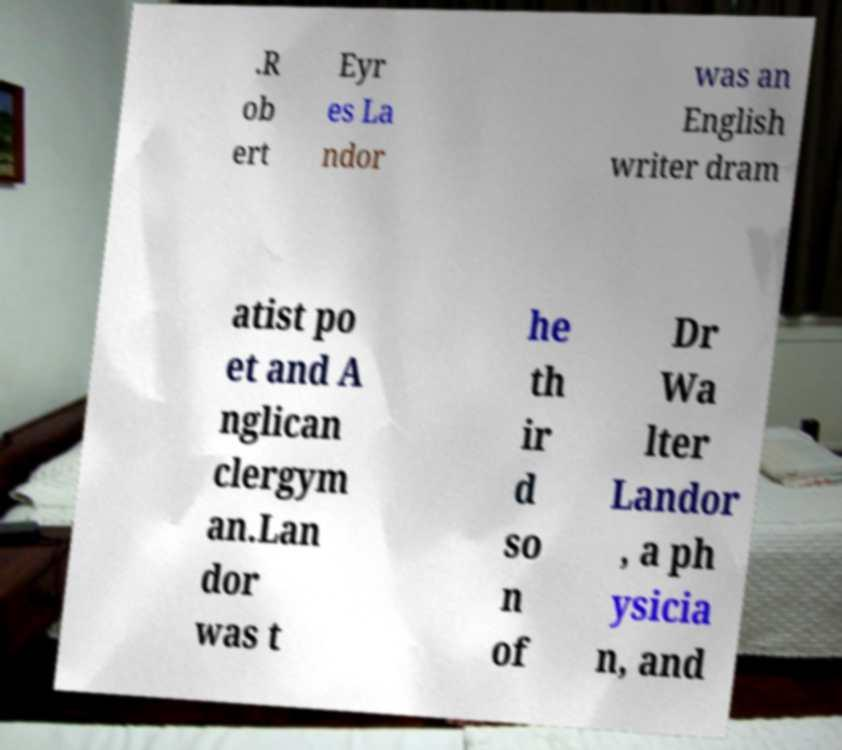Can you read and provide the text displayed in the image?This photo seems to have some interesting text. Can you extract and type it out for me? .R ob ert Eyr es La ndor was an English writer dram atist po et and A nglican clergym an.Lan dor was t he th ir d so n of Dr Wa lter Landor , a ph ysicia n, and 